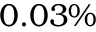<formula> <loc_0><loc_0><loc_500><loc_500>0 . 0 3 \%</formula> 